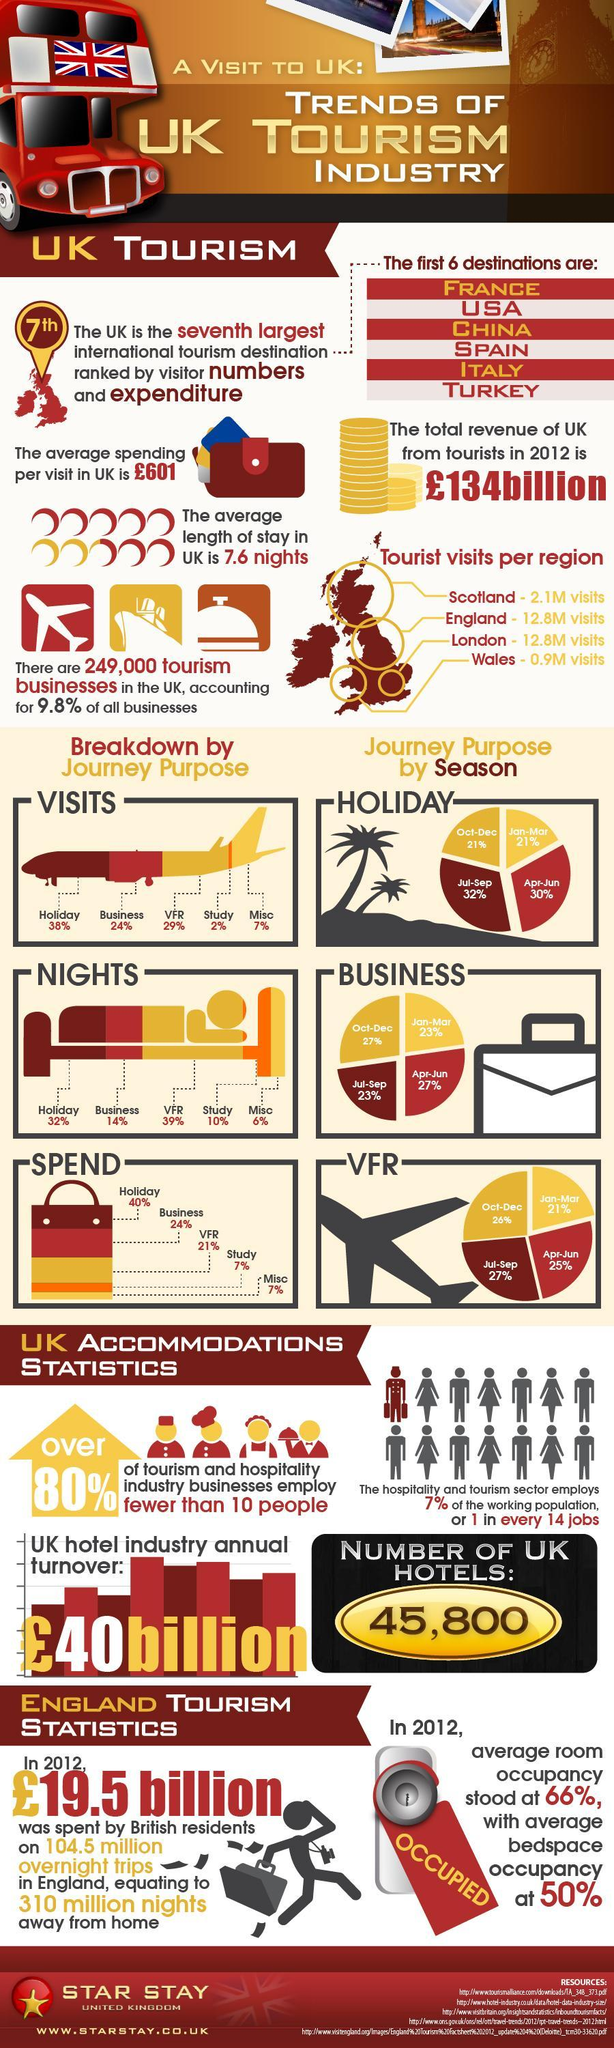Which two regions receive the same number of visitors as per the map?
Answer the question with a short phrase. England, London Which is the second most spending reason? Business Which are the last three destinations among the 7 international tourism destinations ranked by visitor numbers and expenditures? ITALY, TURKEY, The UK For what reason do the most number of visitors come? Holiday What percent of businesses account other than tourism? 90.2% Which season sees the most number of visitors? Jul-Sep 